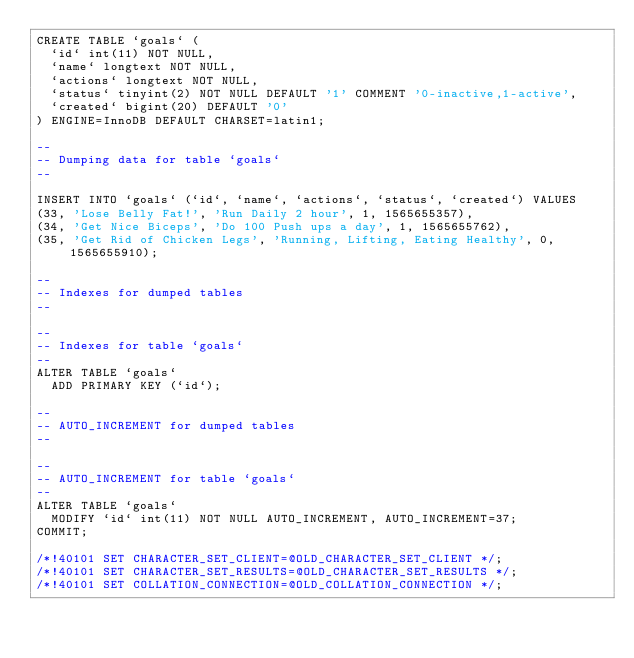Convert code to text. <code><loc_0><loc_0><loc_500><loc_500><_SQL_>CREATE TABLE `goals` (
  `id` int(11) NOT NULL,
  `name` longtext NOT NULL,
  `actions` longtext NOT NULL,
  `status` tinyint(2) NOT NULL DEFAULT '1' COMMENT '0-inactive,1-active',
  `created` bigint(20) DEFAULT '0'
) ENGINE=InnoDB DEFAULT CHARSET=latin1;

--
-- Dumping data for table `goals`
--

INSERT INTO `goals` (`id`, `name`, `actions`, `status`, `created`) VALUES
(33, 'Lose Belly Fat!', 'Run Daily 2 hour', 1, 1565655357),
(34, 'Get Nice Biceps', 'Do 100 Push ups a day', 1, 1565655762),
(35, 'Get Rid of Chicken Legs', 'Running, Lifting, Eating Healthy', 0, 1565655910);

--
-- Indexes for dumped tables
--

--
-- Indexes for table `goals`
--
ALTER TABLE `goals`
  ADD PRIMARY KEY (`id`);

--
-- AUTO_INCREMENT for dumped tables
--

--
-- AUTO_INCREMENT for table `goals`
--
ALTER TABLE `goals`
  MODIFY `id` int(11) NOT NULL AUTO_INCREMENT, AUTO_INCREMENT=37;
COMMIT;

/*!40101 SET CHARACTER_SET_CLIENT=@OLD_CHARACTER_SET_CLIENT */;
/*!40101 SET CHARACTER_SET_RESULTS=@OLD_CHARACTER_SET_RESULTS */;
/*!40101 SET COLLATION_CONNECTION=@OLD_COLLATION_CONNECTION */;
</code> 